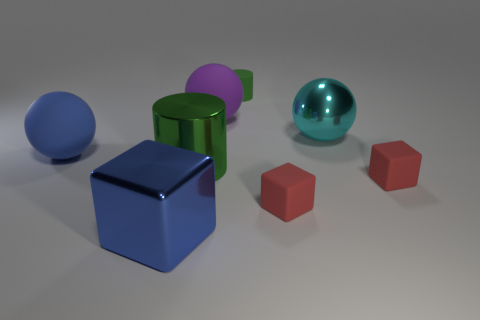Subtract all purple cylinders. Subtract all blue spheres. How many cylinders are left? 2 Add 1 tiny yellow metal balls. How many objects exist? 9 Subtract all cylinders. How many objects are left? 6 Add 8 red things. How many red things exist? 10 Subtract 1 cyan spheres. How many objects are left? 7 Subtract all purple rubber balls. Subtract all big metal cylinders. How many objects are left? 6 Add 5 small matte blocks. How many small matte blocks are left? 7 